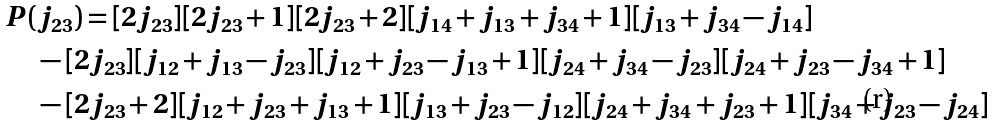Convert formula to latex. <formula><loc_0><loc_0><loc_500><loc_500>P ( & j _ { 2 3 } ) = [ 2 j _ { 2 3 } ] [ 2 j _ { 2 3 } + 1 ] [ 2 j _ { 2 3 } + 2 ] [ j _ { 1 4 } + j _ { 1 3 } + j _ { 3 4 } + 1 ] [ j _ { 1 3 } + j _ { 3 4 } - j _ { 1 4 } ] \\ & - [ 2 j _ { 2 3 } ] [ j _ { 1 2 } + j _ { 1 3 } - j _ { 2 3 } ] [ j _ { 1 2 } + j _ { 2 3 } - j _ { 1 3 } + 1 ] [ j _ { 2 4 } + j _ { 3 4 } - j _ { 2 3 } ] [ j _ { 2 4 } + j _ { 2 3 } - j _ { 3 4 } + 1 ] \\ & - [ 2 j _ { 2 3 } + 2 ] [ j _ { 1 2 } + j _ { 2 3 } + j _ { 1 3 } + 1 ] [ j _ { 1 3 } + j _ { 2 3 } - j _ { 1 2 } ] [ j _ { 2 4 } + j _ { 3 4 } + j _ { 2 3 } + 1 ] [ j _ { 3 4 } + j _ { 2 3 } - j _ { 2 4 } ]</formula> 